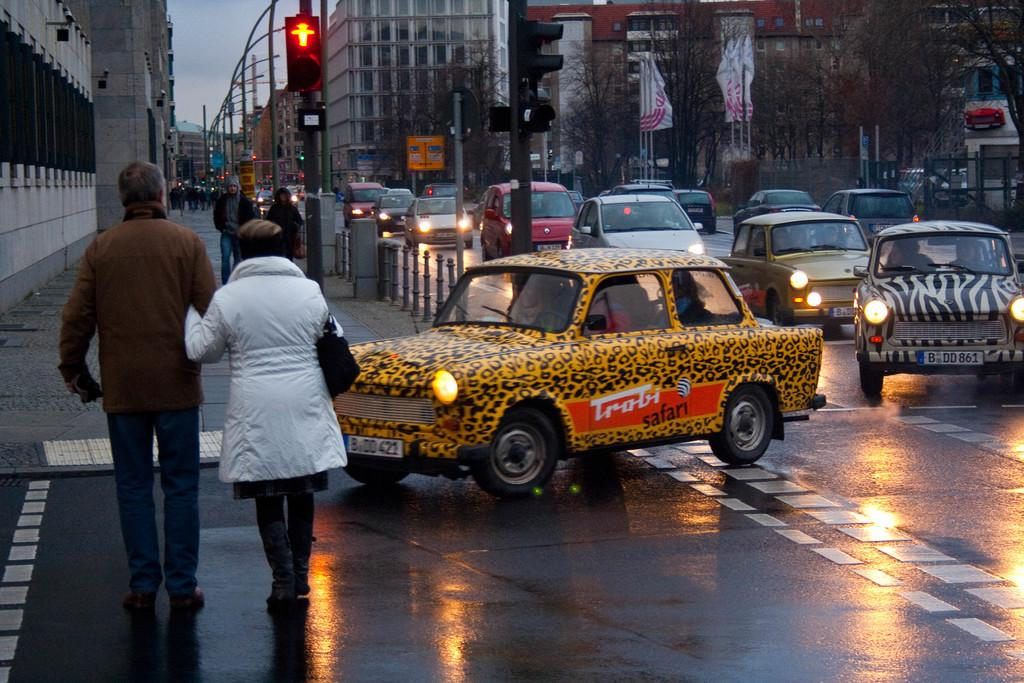<image>
Share a concise interpretation of the image provided. Two people cross the street while a car with animal print painted onto it drives by that says Trobi Safari on the outside 